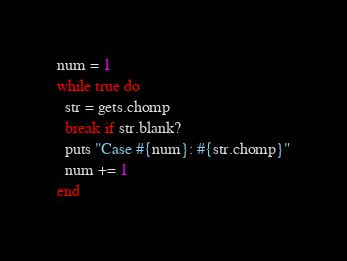Convert code to text. <code><loc_0><loc_0><loc_500><loc_500><_Ruby_>num = 1
while true do
  str = gets.chomp
  break if str.blank?
  puts "Case #{num}: #{str.chomp}"
  num += 1
end</code> 